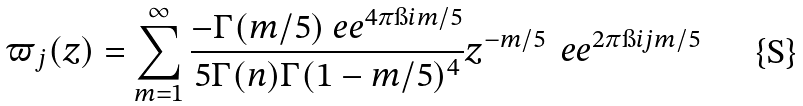Convert formula to latex. <formula><loc_0><loc_0><loc_500><loc_500>\varpi _ { j } ( z ) = \sum _ { m = 1 } ^ { \infty } \frac { - \Gamma ( m / 5 ) \ e e ^ { 4 \pi \i i m / 5 } } { 5 \Gamma ( n ) \Gamma ( 1 - m / 5 ) ^ { 4 } } z ^ { - m / 5 } \, \ e e ^ { 2 \pi \i i j m / 5 }</formula> 